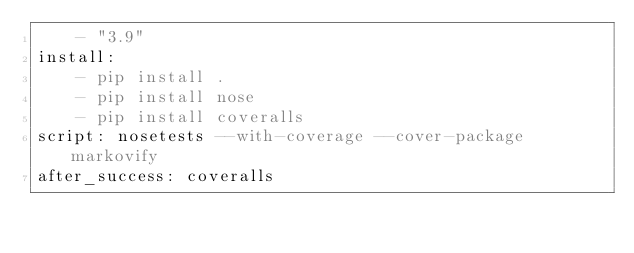Convert code to text. <code><loc_0><loc_0><loc_500><loc_500><_YAML_>    - "3.9"
install:
    - pip install .
    - pip install nose
    - pip install coveralls
script: nosetests --with-coverage --cover-package markovify
after_success: coveralls
</code> 